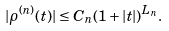<formula> <loc_0><loc_0><loc_500><loc_500>| \rho ^ { ( n ) } ( t ) | \leq C _ { n } ( 1 + | t | ) ^ { L _ { n } } .</formula> 